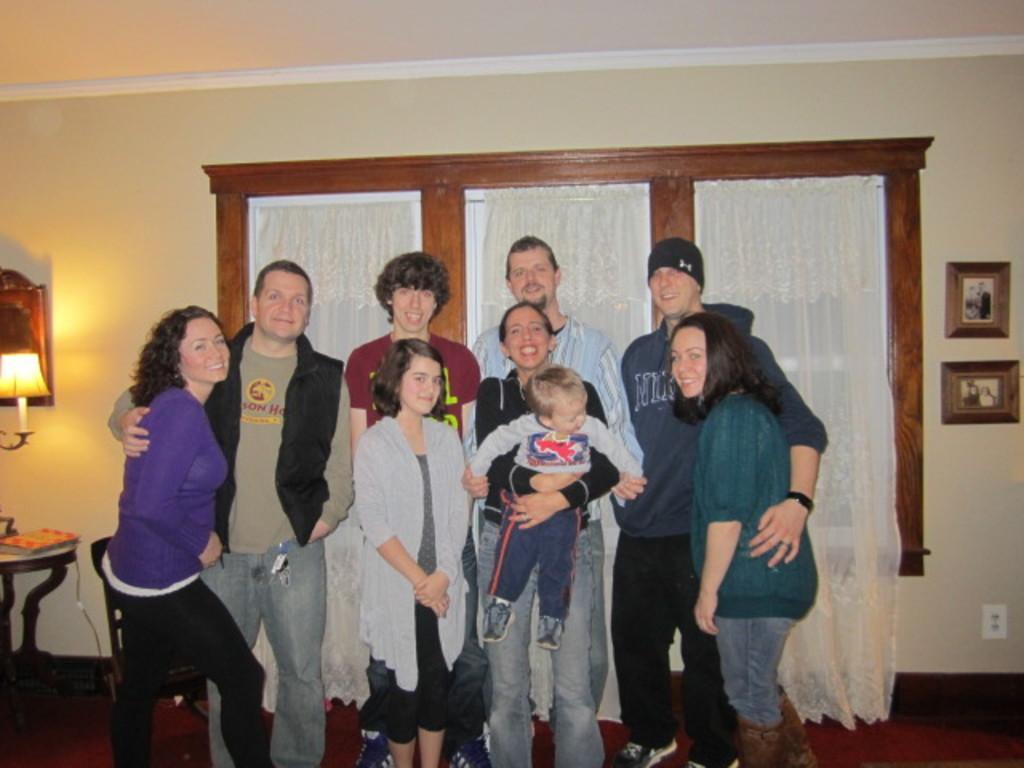Please provide a concise description of this image. In the picture we can see some people are standing and woman is holding a baby and they all are smiling and behind them we can see a window with a wooden frame to it and beside it we can see a table on it we can see a book and a lamp stand with a lamp and on the other side we can see a photo frames with photos on it. 